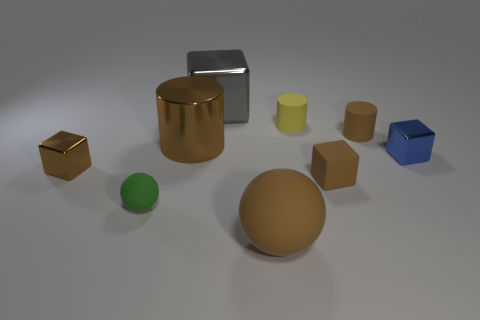Subtract all brown blocks. How many blocks are left? 2 Subtract all small matte cylinders. How many cylinders are left? 1 Subtract 0 blue spheres. How many objects are left? 9 Subtract all balls. How many objects are left? 7 Subtract 2 cylinders. How many cylinders are left? 1 Subtract all brown cylinders. Subtract all green balls. How many cylinders are left? 1 Subtract all purple blocks. How many brown balls are left? 1 Subtract all green things. Subtract all tiny green rubber things. How many objects are left? 7 Add 3 tiny rubber cylinders. How many tiny rubber cylinders are left? 5 Add 2 big brown metal spheres. How many big brown metal spheres exist? 2 